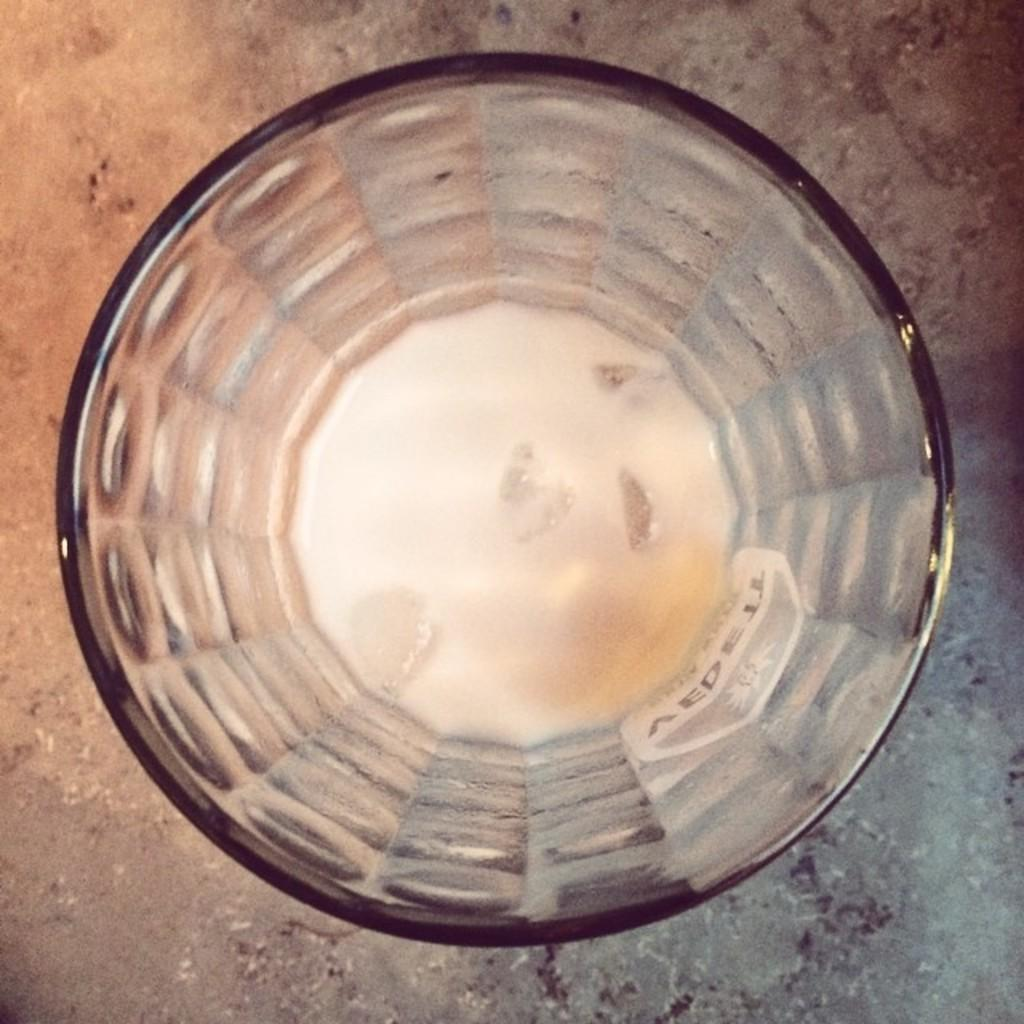What object is present in the image? There is a glass tumbler in the image. Can you hear the goldfish crying in the image? There is no goldfish present in the image, and therefore no such activity can be observed. 